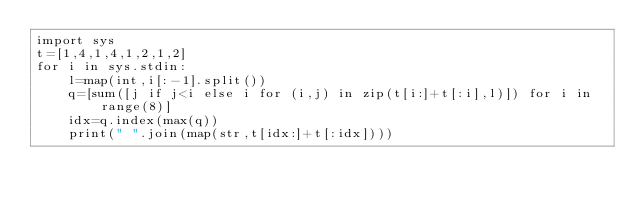<code> <loc_0><loc_0><loc_500><loc_500><_Python_>import sys
t=[1,4,1,4,1,2,1,2]
for i in sys.stdin:
    l=map(int,i[:-1].split())
    q=[sum([j if j<i else i for (i,j) in zip(t[i:]+t[:i],l)]) for i in range(8)]
    idx=q.index(max(q))
    print(" ".join(map(str,t[idx:]+t[:idx])))
</code> 